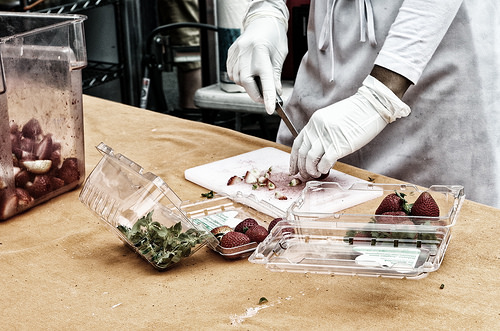<image>
Can you confirm if the glove is on the strawberry? Yes. Looking at the image, I can see the glove is positioned on top of the strawberry, with the strawberry providing support. 